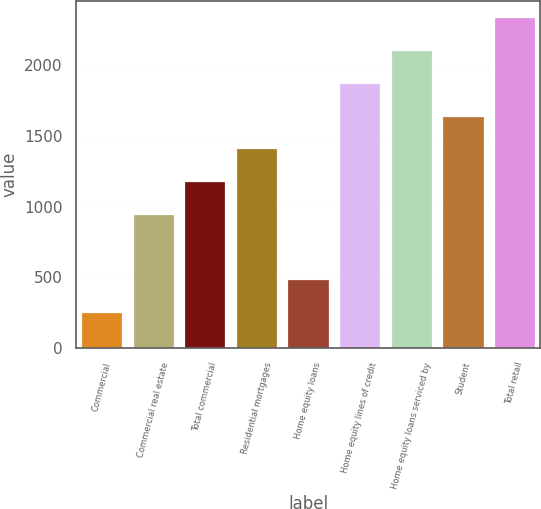Convert chart to OTSL. <chart><loc_0><loc_0><loc_500><loc_500><bar_chart><fcel>Commercial<fcel>Commercial real estate<fcel>Total commercial<fcel>Residential mortgages<fcel>Home equity loans<fcel>Home equity lines of credit<fcel>Home equity loans serviced by<fcel>Student<fcel>Total retail<nl><fcel>257.2<fcel>950.8<fcel>1182<fcel>1413.2<fcel>488.4<fcel>1875.6<fcel>2106.8<fcel>1644.4<fcel>2338<nl></chart> 